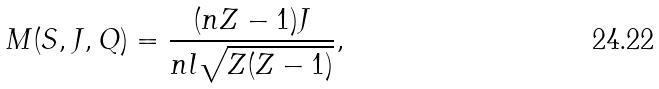Convert formula to latex. <formula><loc_0><loc_0><loc_500><loc_500>M ( S , { J } , Q ) = \frac { ( n Z - 1 ) J } { n l \sqrt { Z ( Z - 1 ) } } ,</formula> 